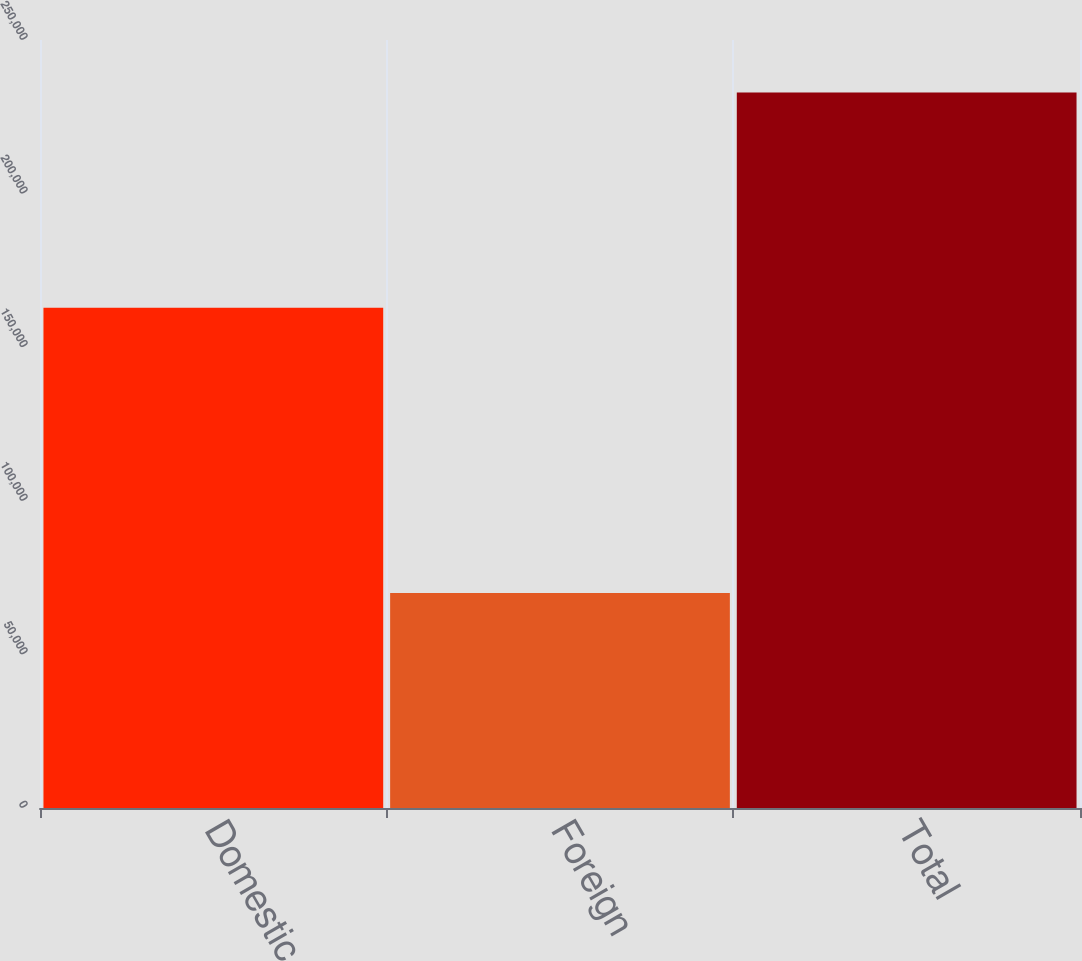Convert chart. <chart><loc_0><loc_0><loc_500><loc_500><bar_chart><fcel>Domestic<fcel>Foreign<fcel>Total<nl><fcel>162880<fcel>69996<fcel>232876<nl></chart> 